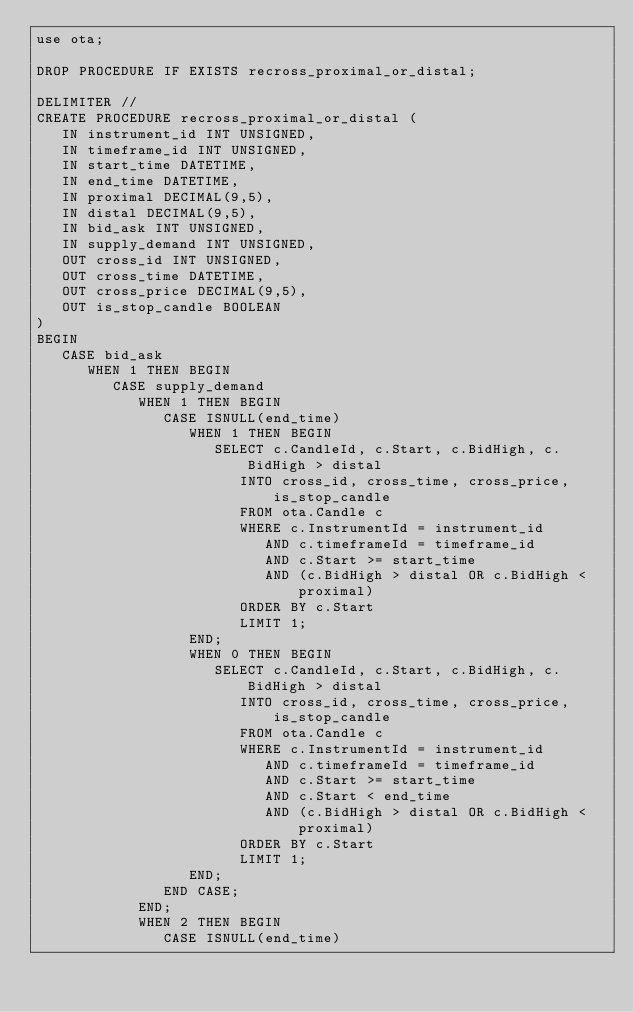<code> <loc_0><loc_0><loc_500><loc_500><_SQL_>use ota;

DROP PROCEDURE IF EXISTS recross_proximal_or_distal;

DELIMITER //
CREATE PROCEDURE recross_proximal_or_distal (
   IN instrument_id INT UNSIGNED,
   IN timeframe_id INT UNSIGNED,
   IN start_time DATETIME,
   IN end_time DATETIME,
   IN proximal DECIMAL(9,5),
   IN distal DECIMAL(9,5),
   IN bid_ask INT UNSIGNED,
   IN supply_demand INT UNSIGNED,
   OUT cross_id INT UNSIGNED,
   OUT cross_time DATETIME,
   OUT cross_price DECIMAL(9,5),
   OUT is_stop_candle BOOLEAN
)
BEGIN
   CASE bid_ask
      WHEN 1 THEN BEGIN
         CASE supply_demand
            WHEN 1 THEN BEGIN
               CASE ISNULL(end_time)
                  WHEN 1 THEN BEGIN
                     SELECT c.CandleId, c.Start, c.BidHigh, c.BidHigh > distal
                        INTO cross_id, cross_time, cross_price, is_stop_candle
                        FROM ota.Candle c
                        WHERE c.InstrumentId = instrument_id
                           AND c.timeframeId = timeframe_id
                           AND c.Start >= start_time
                           AND (c.BidHigh > distal OR c.BidHigh < proximal)
                        ORDER BY c.Start
                        LIMIT 1;
                  END;
                  WHEN 0 THEN BEGIN
                     SELECT c.CandleId, c.Start, c.BidHigh, c.BidHigh > distal
                        INTO cross_id, cross_time, cross_price, is_stop_candle
                        FROM ota.Candle c
                        WHERE c.InstrumentId = instrument_id
                           AND c.timeframeId = timeframe_id
                           AND c.Start >= start_time
                           AND c.Start < end_time
                           AND (c.BidHigh > distal OR c.BidHigh < proximal)
                        ORDER BY c.Start
                        LIMIT 1;
                  END;
               END CASE;
            END;
            WHEN 2 THEN BEGIN
               CASE ISNULL(end_time)</code> 